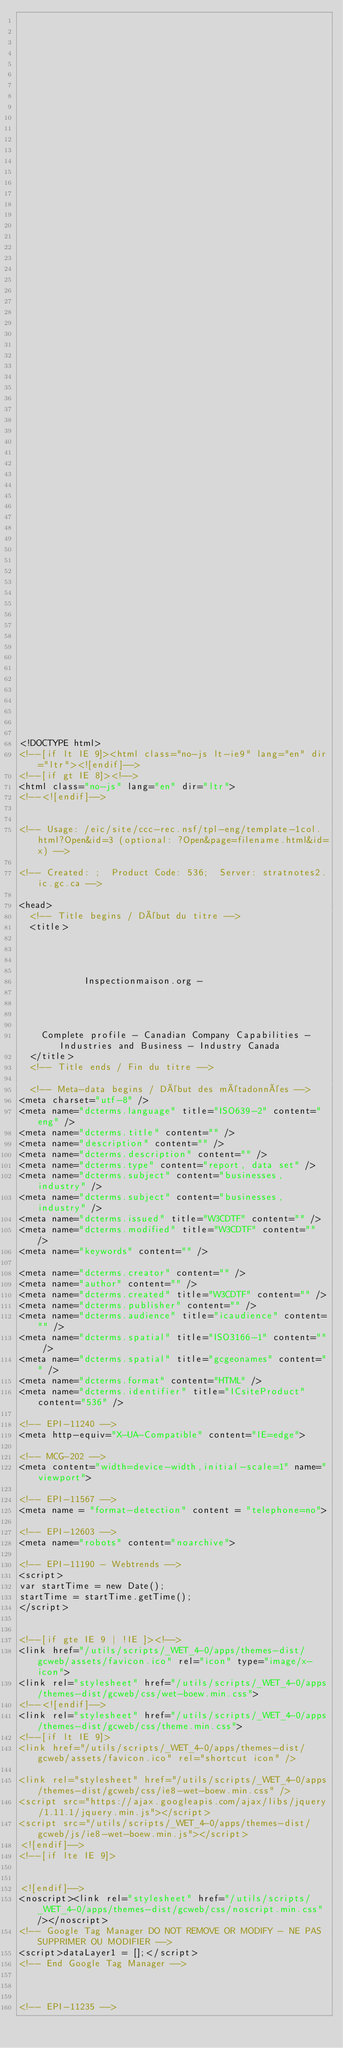Convert code to text. <code><loc_0><loc_0><loc_500><loc_500><_HTML_>


















	






  
  
  
  































	
	
	



<!DOCTYPE html>
<!--[if lt IE 9]><html class="no-js lt-ie9" lang="en" dir="ltr"><![endif]-->
<!--[if gt IE 8]><!-->
<html class="no-js" lang="en" dir="ltr">
<!--<![endif]-->


<!-- Usage: /eic/site/ccc-rec.nsf/tpl-eng/template-1col.html?Open&id=3 (optional: ?Open&page=filename.html&id=x) -->

<!-- Created: ;  Product Code: 536;  Server: stratnotes2.ic.gc.ca -->

<head>
	<!-- Title begins / Début du titre -->
	<title>
    
            
        
          
            Inspectionmaison.org -
          
        
      
    
    Complete profile - Canadian Company Capabilities - Industries and Business - Industry Canada
  </title>
	<!-- Title ends / Fin du titre -->
 
	<!-- Meta-data begins / Début des métadonnées -->
<meta charset="utf-8" />
<meta name="dcterms.language" title="ISO639-2" content="eng" />
<meta name="dcterms.title" content="" />
<meta name="description" content="" />
<meta name="dcterms.description" content="" />
<meta name="dcterms.type" content="report, data set" />
<meta name="dcterms.subject" content="businesses, industry" />
<meta name="dcterms.subject" content="businesses, industry" />
<meta name="dcterms.issued" title="W3CDTF" content="" />
<meta name="dcterms.modified" title="W3CDTF" content="" />
<meta name="keywords" content="" />

<meta name="dcterms.creator" content="" />
<meta name="author" content="" />
<meta name="dcterms.created" title="W3CDTF" content="" />
<meta name="dcterms.publisher" content="" />
<meta name="dcterms.audience" title="icaudience" content="" />
<meta name="dcterms.spatial" title="ISO3166-1" content="" />
<meta name="dcterms.spatial" title="gcgeonames" content="" />
<meta name="dcterms.format" content="HTML" />
<meta name="dcterms.identifier" title="ICsiteProduct" content="536" />

<!-- EPI-11240 -->
<meta http-equiv="X-UA-Compatible" content="IE=edge">

<!-- MCG-202 -->
<meta content="width=device-width,initial-scale=1" name="viewport">

<!-- EPI-11567 -->
<meta name = "format-detection" content = "telephone=no">

<!-- EPI-12603 -->
<meta name="robots" content="noarchive">

<!-- EPI-11190 - Webtrends -->
<script>
var startTime = new Date();
startTime = startTime.getTime();
</script>


<!--[if gte IE 9 | !IE ]><!-->
<link href="/utils/scripts/_WET_4-0/apps/themes-dist/gcweb/assets/favicon.ico" rel="icon" type="image/x-icon">
<link rel="stylesheet" href="/utils/scripts/_WET_4-0/apps/themes-dist/gcweb/css/wet-boew.min.css">
<!--<![endif]-->
<link rel="stylesheet" href="/utils/scripts/_WET_4-0/apps/themes-dist/gcweb/css/theme.min.css">
<!--[if lt IE 9]>
<link href="/utils/scripts/_WET_4-0/apps/themes-dist/gcweb/assets/favicon.ico" rel="shortcut icon" />

<link rel="stylesheet" href="/utils/scripts/_WET_4-0/apps/themes-dist/gcweb/css/ie8-wet-boew.min.css" />
<script src="https://ajax.googleapis.com/ajax/libs/jquery/1.11.1/jquery.min.js"></script>
<script src="/utils/scripts/_WET_4-0/apps/themes-dist/gcweb/js/ie8-wet-boew.min.js"></script>
<![endif]-->
<!--[if lte IE 9]>


<![endif]-->
<noscript><link rel="stylesheet" href="/utils/scripts/_WET_4-0/apps/themes-dist/gcweb/css/noscript.min.css" /></noscript>
<!-- Google Tag Manager DO NOT REMOVE OR MODIFY - NE PAS SUPPRIMER OU MODIFIER -->
<script>dataLayer1 = [];</script>
<!-- End Google Tag Manager -->



<!-- EPI-11235 --></code> 